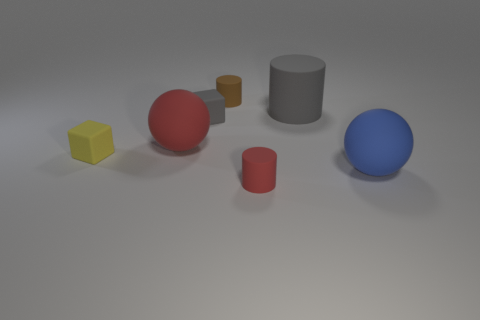Add 1 tiny green matte cylinders. How many objects exist? 8 Subtract all cubes. How many objects are left? 5 Add 2 yellow blocks. How many yellow blocks exist? 3 Subtract 1 yellow blocks. How many objects are left? 6 Subtract all small gray matte cubes. Subtract all blue matte spheres. How many objects are left? 5 Add 5 rubber cubes. How many rubber cubes are left? 7 